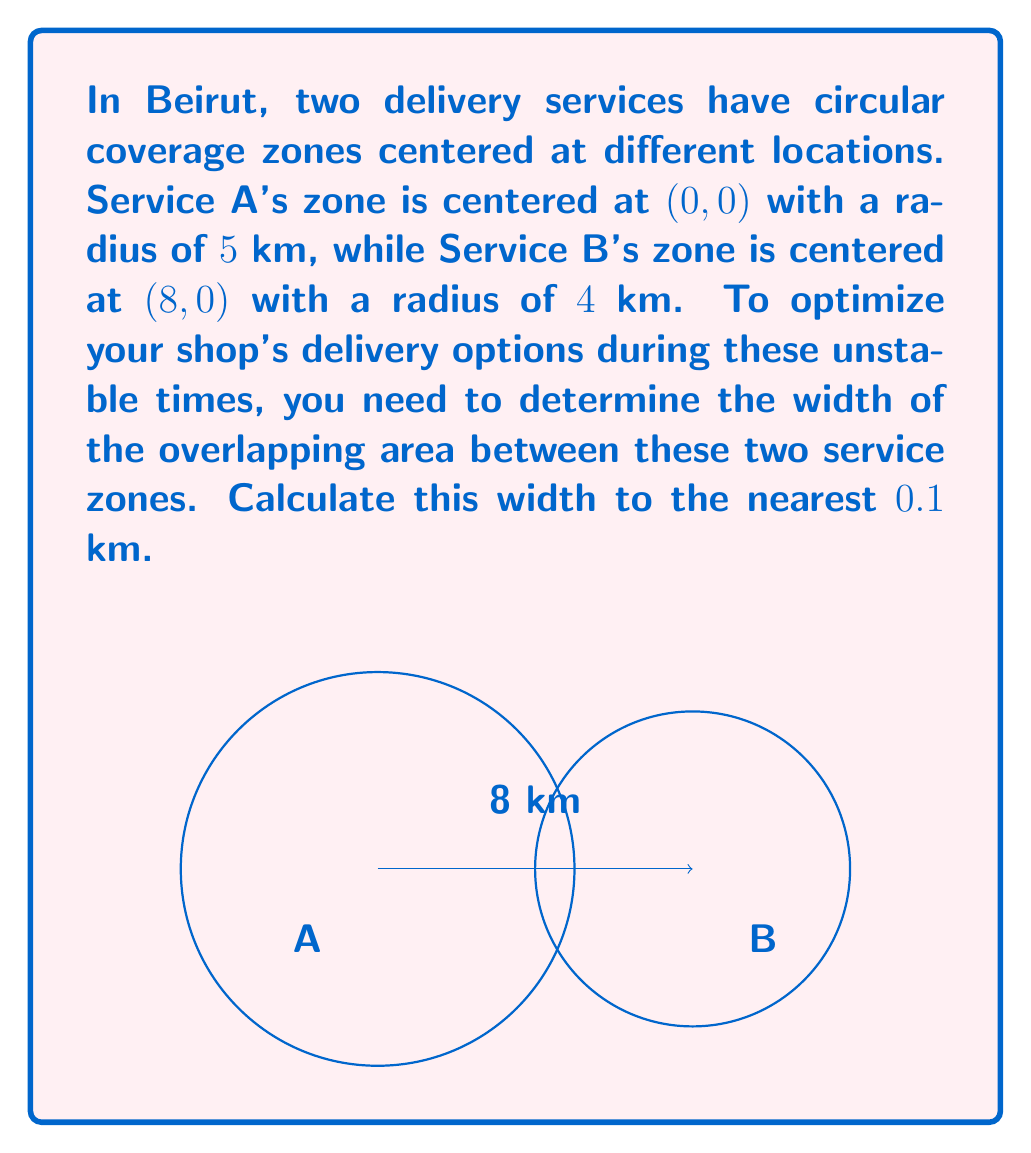What is the answer to this math problem? Let's approach this step-by-step:

1) The width of the overlapping area is the distance between the two points where the circles intersect.

2) To find these points, we need to solve the system of equations for the two circles:

   Circle A: $x^2 + y^2 = 25$
   Circle B: $(x-8)^2 + y^2 = 16$

3) Subtracting the second equation from the first:

   $x^2 - (x-8)^2 = 25 - 16$
   $x^2 - (x^2 - 16x + 64) = 9$
   $16x - 64 = 9$
   $16x = 73$
   $x = \frac{73}{16} = 4.5625$

4) This x-coordinate represents the midpoint of the overlap width. To find y, we can substitute this x value into either circle equation. Let's use Circle A:

   $y^2 = 25 - x^2 = 25 - 4.5625^2 = 4.1796$
   $y = \pm \sqrt{4.1796} = \pm 2.0444$

5) So, the points of intersection are (4.5625, 2.0444) and (4.5625, -2.0444).

6) The width of the overlap is twice the y-coordinate:

   Width = $2 * 2.0444 = 4.0888$ km

7) Rounding to the nearest 0.1 km:

   Width ≈ 4.1 km
Answer: 4.1 km 